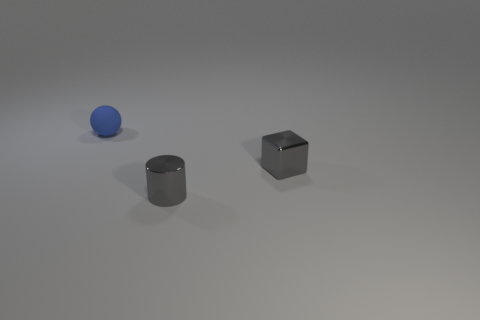Add 2 gray shiny objects. How many objects exist? 5 Subtract all spheres. How many objects are left? 2 Add 2 blue rubber spheres. How many blue rubber spheres are left? 3 Add 1 yellow shiny cylinders. How many yellow shiny cylinders exist? 1 Subtract 0 cyan balls. How many objects are left? 3 Subtract all gray things. Subtract all yellow shiny balls. How many objects are left? 1 